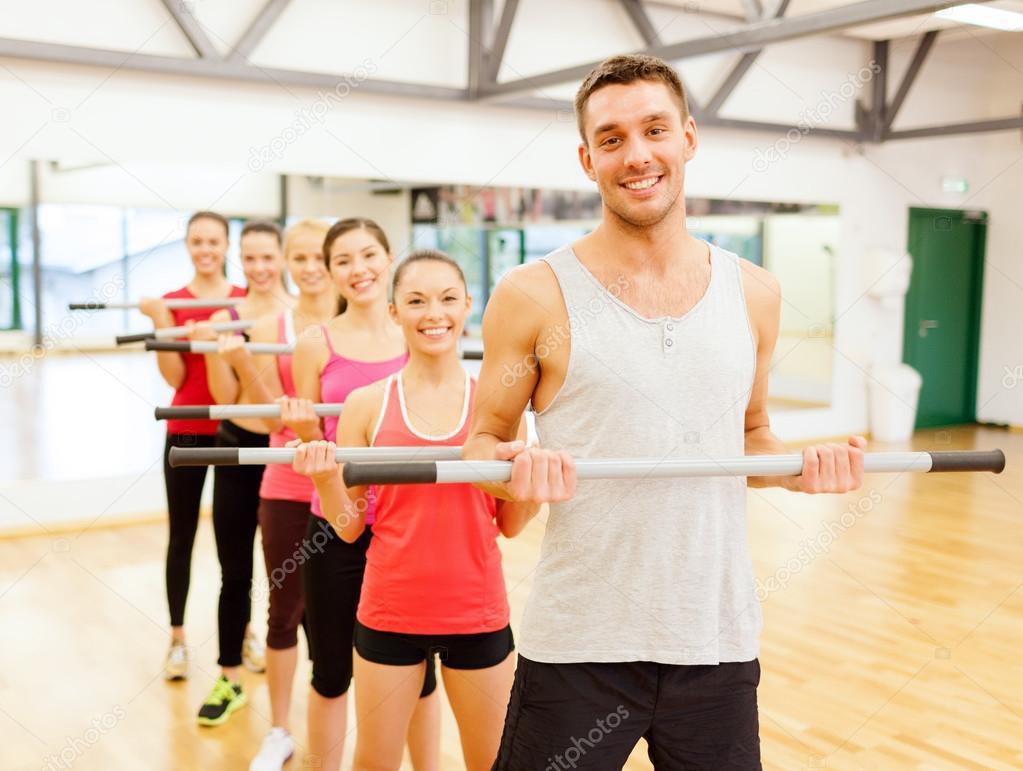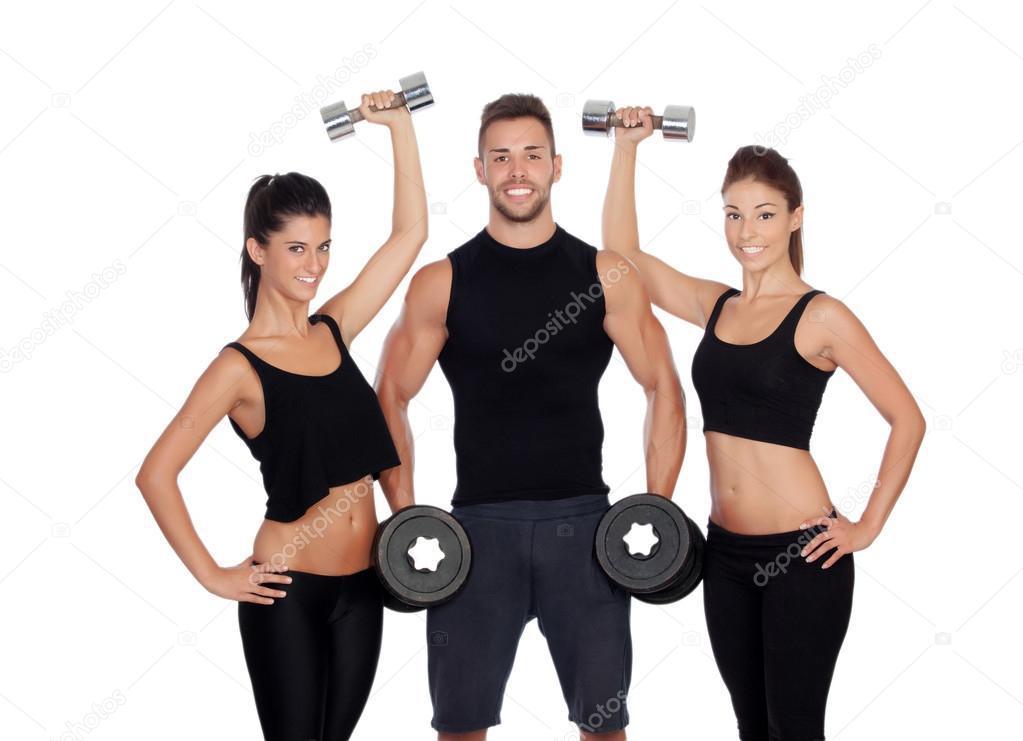The first image is the image on the left, the second image is the image on the right. Considering the images on both sides, is "In at least one image there are three people lifting weights." valid? Answer yes or no. Yes. The first image is the image on the left, the second image is the image on the right. Examine the images to the left and right. Is the description "One image shows a man holding something weighted in each hand, standing in front of at least four women doing the same workout." accurate? Answer yes or no. Yes. 